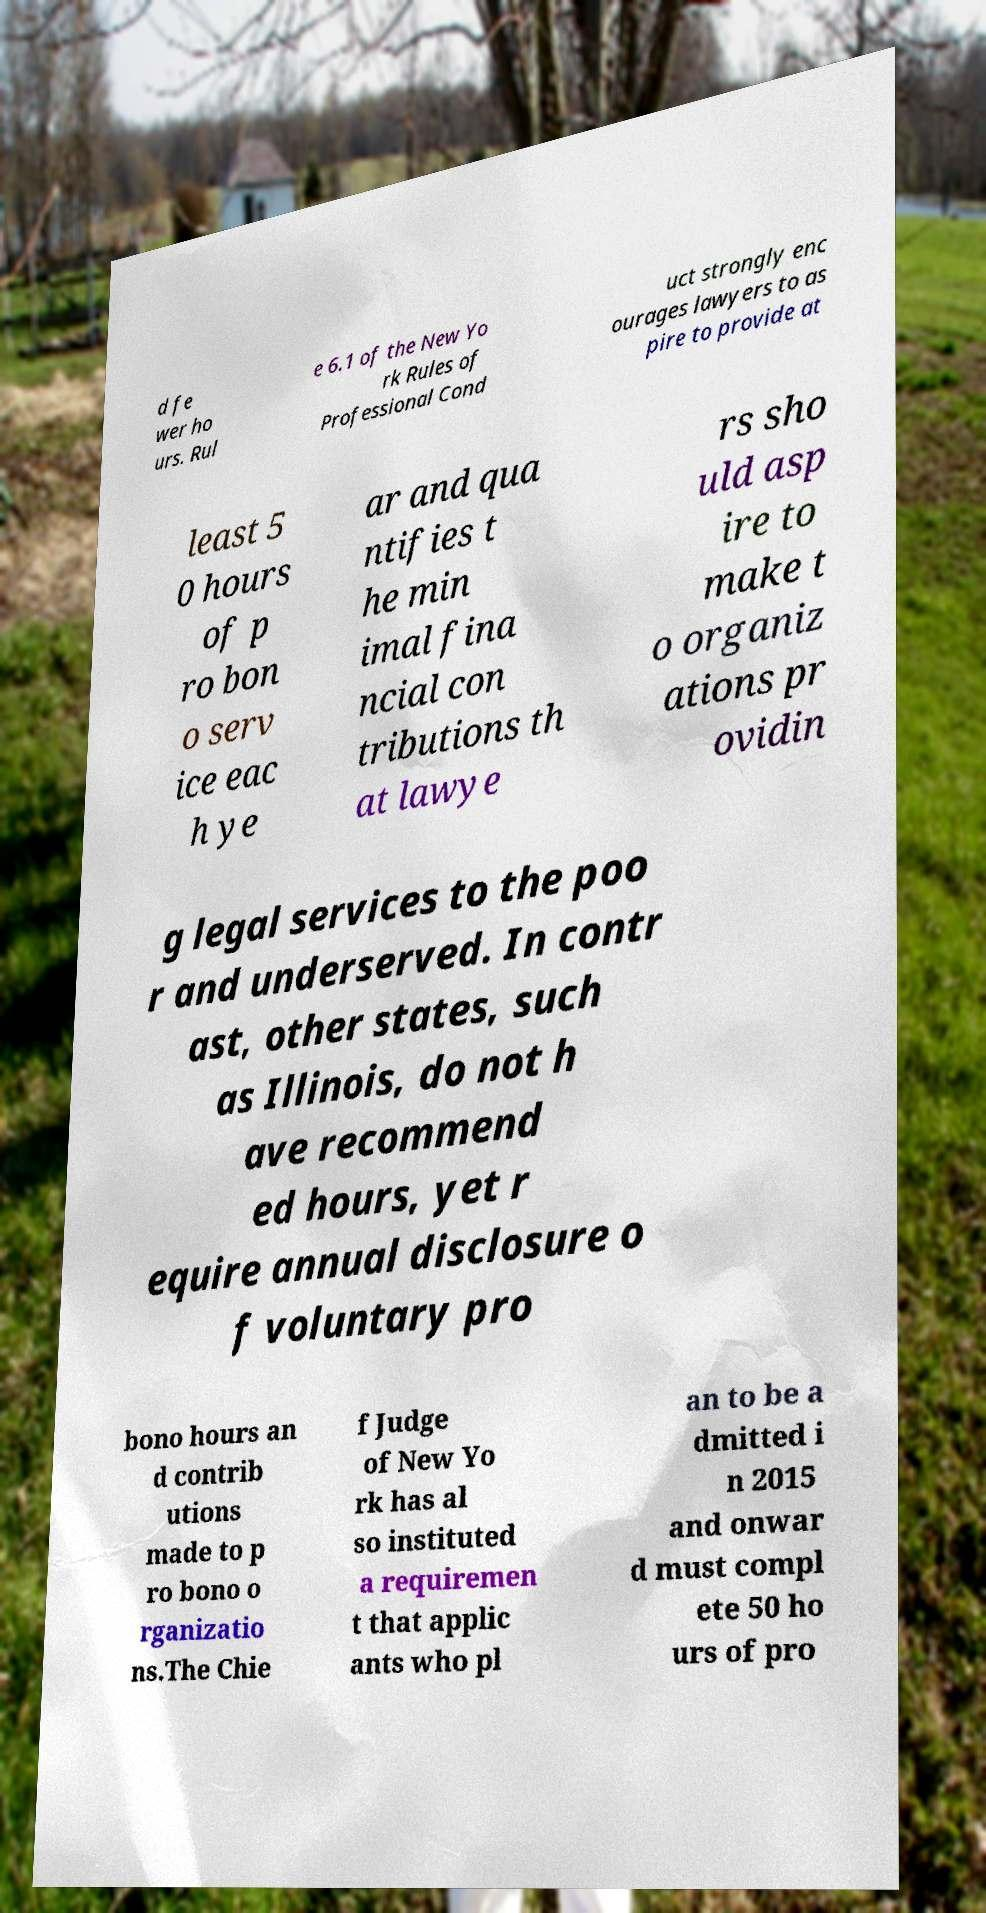There's text embedded in this image that I need extracted. Can you transcribe it verbatim? d fe wer ho urs. Rul e 6.1 of the New Yo rk Rules of Professional Cond uct strongly enc ourages lawyers to as pire to provide at least 5 0 hours of p ro bon o serv ice eac h ye ar and qua ntifies t he min imal fina ncial con tributions th at lawye rs sho uld asp ire to make t o organiz ations pr ovidin g legal services to the poo r and underserved. In contr ast, other states, such as Illinois, do not h ave recommend ed hours, yet r equire annual disclosure o f voluntary pro bono hours an d contrib utions made to p ro bono o rganizatio ns.The Chie f Judge of New Yo rk has al so instituted a requiremen t that applic ants who pl an to be a dmitted i n 2015 and onwar d must compl ete 50 ho urs of pro 